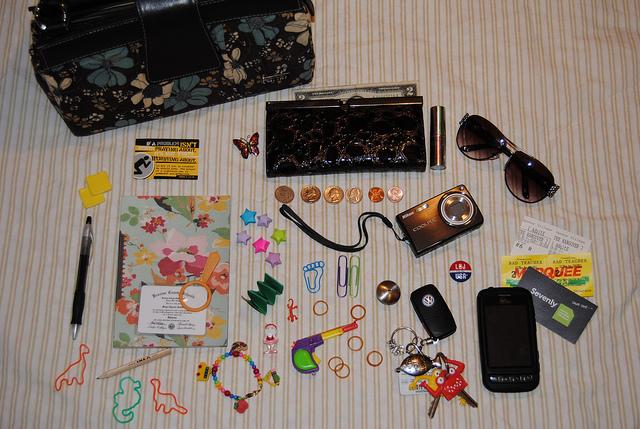How many sunglasses?
Be succinct. 1. Are these phones usable?
Short answer required. Yes. How many items are placed on the tablecloth?
Keep it brief. 24. What color is the tablecloth?
Quick response, please. Orange and white. Are there glass' windows on the photo?
Quick response, please. No. How old do you think this suitcase is?
Concise answer only. 10 years. What is the little toy gun called?
Concise answer only. Shooter. How much money is shown?
Concise answer only. 82 cents. Which device could be a camera?
Concise answer only. Nikon coolpix. What age group are these toys for?
Write a very short answer. 8. 